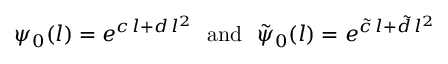<formula> <loc_0><loc_0><loc_500><loc_500>\psi _ { 0 } ( l ) = e ^ { c \, l + d \, l ^ { 2 } } \ \ a n d \quad t i l d e { \psi } _ { 0 } ( l ) = e ^ { \tilde { c } \, l + \tilde { d } \, l ^ { 2 } }</formula> 